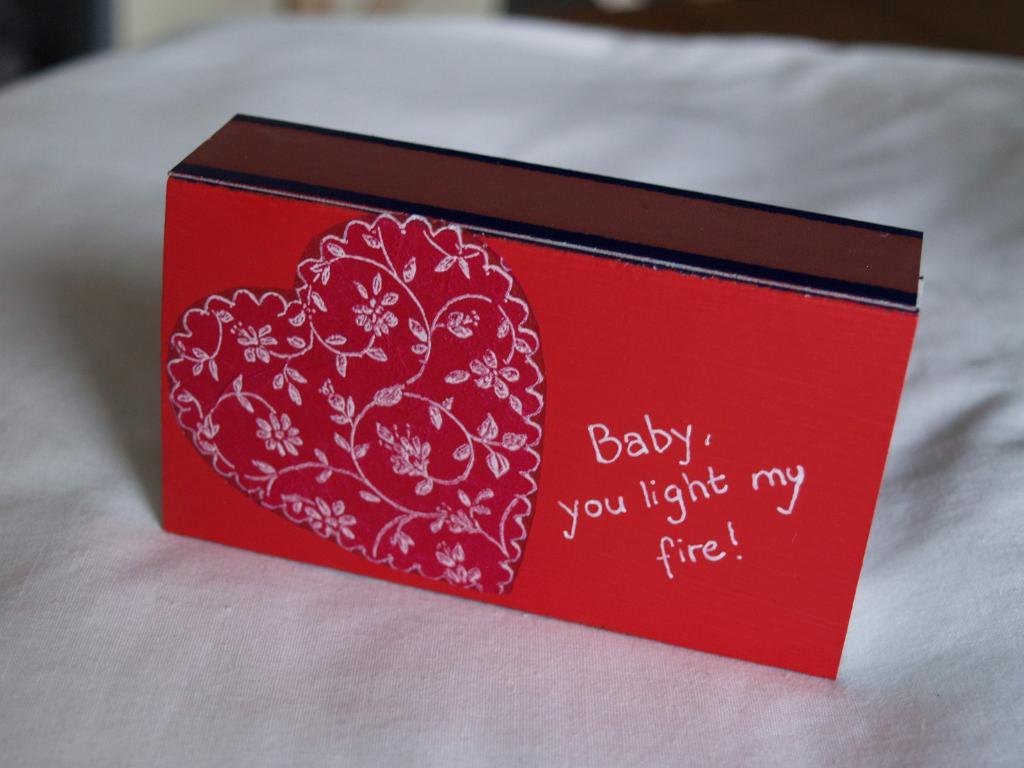Who lights my fire?
Keep it short and to the point. Baby. 